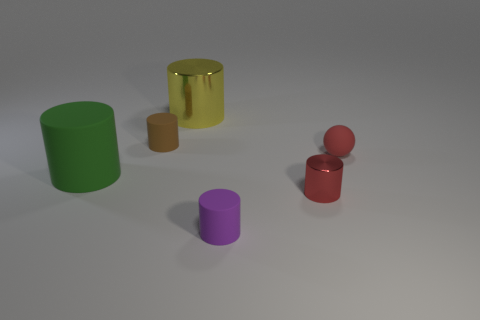Subtract all brown cylinders. How many cylinders are left? 4 Subtract all yellow cylinders. How many cylinders are left? 4 Add 1 large yellow cylinders. How many objects exist? 7 Subtract 2 cylinders. How many cylinders are left? 3 Subtract all purple cylinders. Subtract all green blocks. How many cylinders are left? 4 Subtract all cylinders. How many objects are left? 1 Subtract 0 green cubes. How many objects are left? 6 Subtract all green metallic cylinders. Subtract all tiny brown matte objects. How many objects are left? 5 Add 2 large green objects. How many large green objects are left? 3 Add 3 small matte balls. How many small matte balls exist? 4 